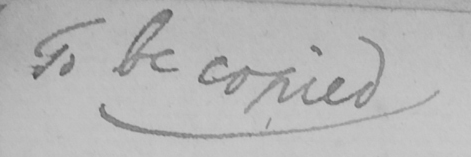Can you tell me what this handwritten text says? To be copied 